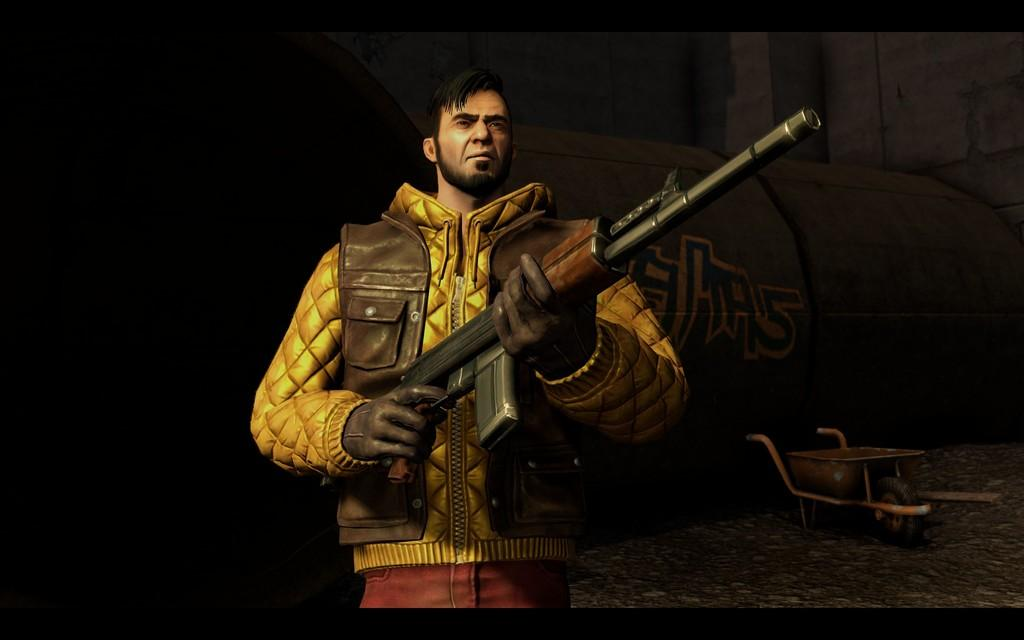What is the main subject of the image? There is a man in the image. What is the man holding in the image? The man is holding a rifle. What can be seen on the ground in the image? There is a cart on the ground in the image. What else is present in the image besides the man and the cart? There are other objects present in the image. How would you describe the lighting in the image? The background of the image is dark. What type of chess piece is the man moving in the image? There is no chess piece present in the image; the man is holding a rifle. Who is the uncle in the image? There is no mention of an uncle in the image or the provided facts. 